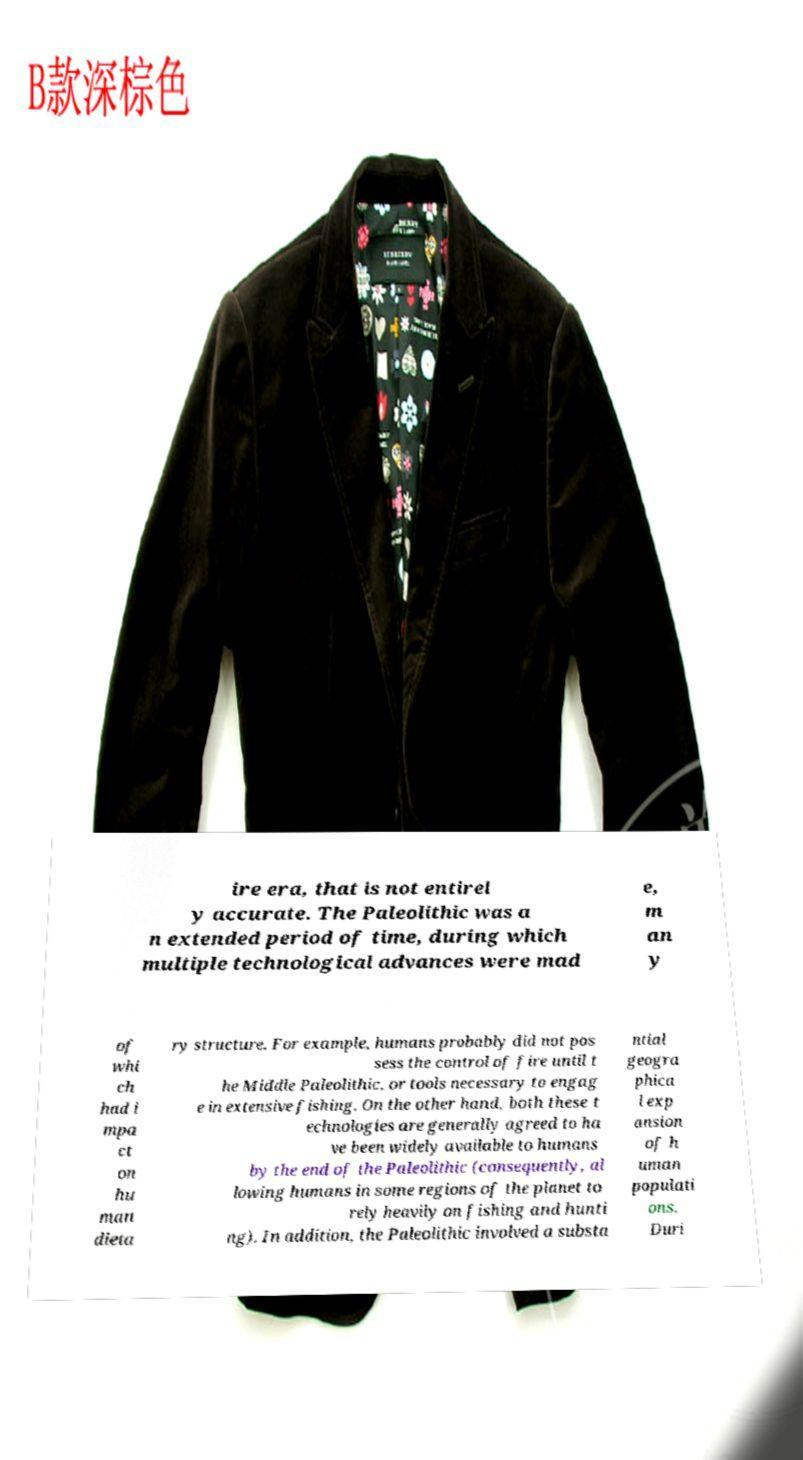Can you read and provide the text displayed in the image?This photo seems to have some interesting text. Can you extract and type it out for me? ire era, that is not entirel y accurate. The Paleolithic was a n extended period of time, during which multiple technological advances were mad e, m an y of whi ch had i mpa ct on hu man dieta ry structure. For example, humans probably did not pos sess the control of fire until t he Middle Paleolithic, or tools necessary to engag e in extensive fishing. On the other hand, both these t echnologies are generally agreed to ha ve been widely available to humans by the end of the Paleolithic (consequently, al lowing humans in some regions of the planet to rely heavily on fishing and hunti ng). In addition, the Paleolithic involved a substa ntial geogra phica l exp ansion of h uman populati ons. Duri 